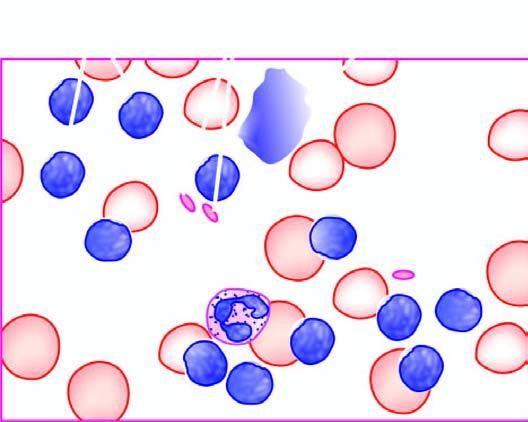what is there?
Answer the question using a single word or phrase. Large excess of mature and small differentiated lymphocytes and some degenerated forms appearing as bare smudged nuclei 